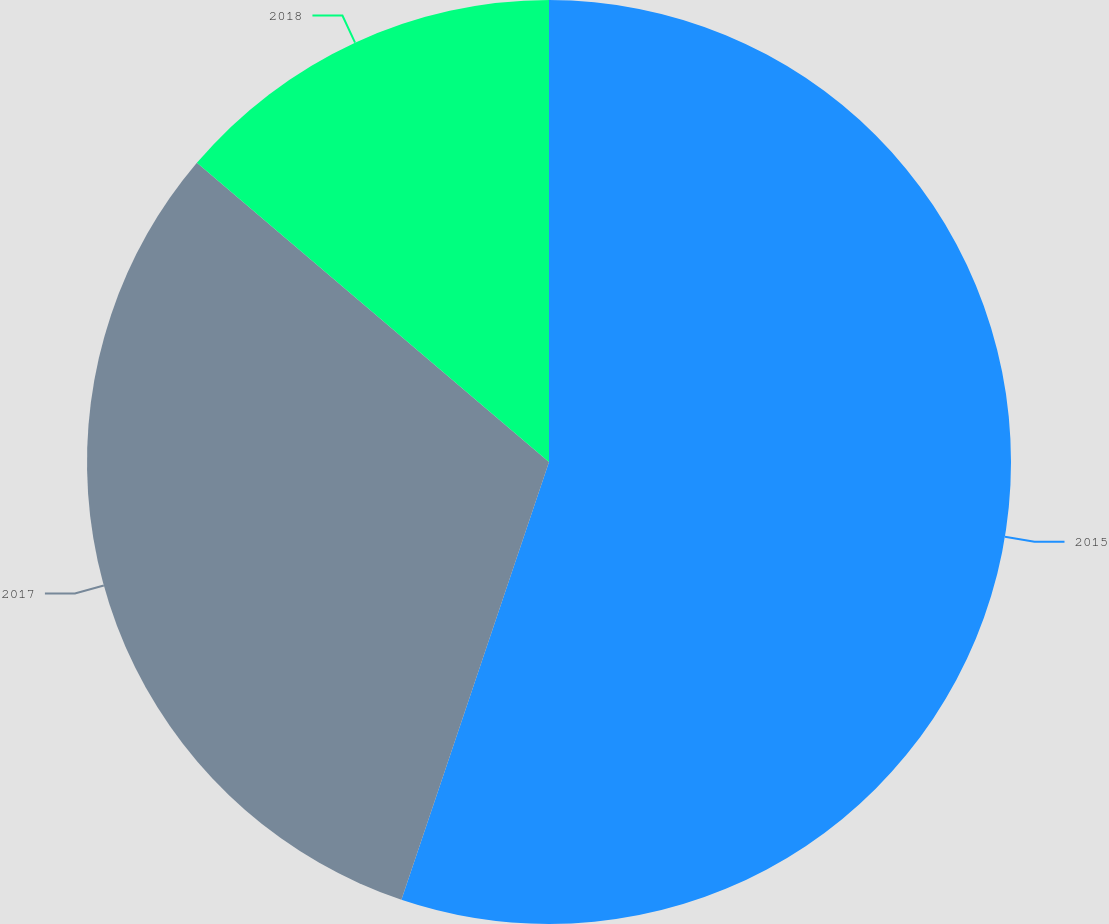<chart> <loc_0><loc_0><loc_500><loc_500><pie_chart><fcel>2015<fcel>2017<fcel>2018<nl><fcel>55.17%<fcel>31.03%<fcel>13.79%<nl></chart> 